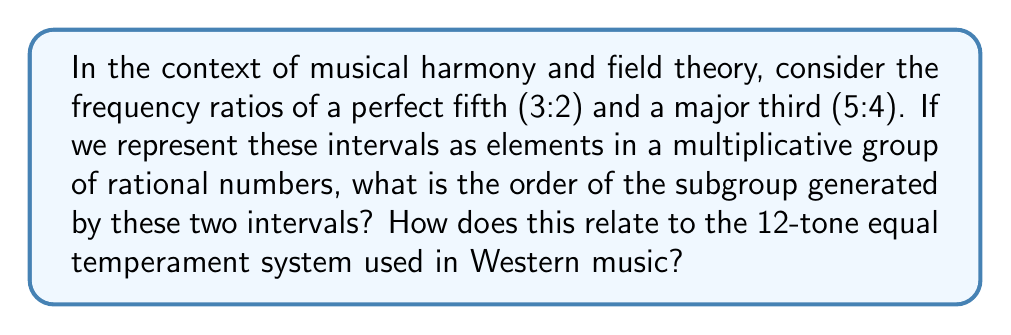Could you help me with this problem? Let's approach this step-by-step:

1) First, we need to understand what we're working with:
   - Perfect fifth: $\frac{3}{2}$
   - Major third: $\frac{5}{4}$

2) These ratios form elements in the multiplicative group of positive rational numbers, $\mathbb{Q}^+$.

3) To find the order of the subgroup generated by these elements, we need to find the smallest positive integer $n$ such that:

   $(\frac{3}{2})^a \cdot (\frac{5}{4})^b = 1$ for some integers $a$ and $b$, not both zero.

4) This is equivalent to solving:

   $3^a \cdot 5^b = 2^a \cdot 4^b$

5) Which simplifies to:

   $3^a \cdot 5^b = 2^{a+2b}$

6) For this to be true, we must have:
   $a = 0$ and $b = 0$, or
   $a = 12$ and $b = -12$

7) The smallest non-zero solution is $a = 12$ and $b = -12$. This means:

   $(\frac{3}{2})^{12} \cdot (\frac{5}{4})^{-12} = 1$

8) Therefore, the order of the subgroup is 12.

9) This relates to the 12-tone equal temperament system in Western music:
   - In this system, an octave is divided into 12 equal semitones.
   - The frequency ratio for a semitone is $2^{\frac{1}{12}}$.
   - A perfect fifth in this system is approximated by 7 semitones: $(2^{\frac{1}{12}})^7 \approx 1.498 \approx \frac{3}{2}$
   - A major third is approximated by 4 semitones: $(2^{\frac{1}{12}})^4 \approx 1.260 \approx \frac{5}{4}$

10) The fact that the subgroup has order 12 mathematically justifies the use of a 12-tone system, as it closely approximates these important musical intervals.
Answer: 12 